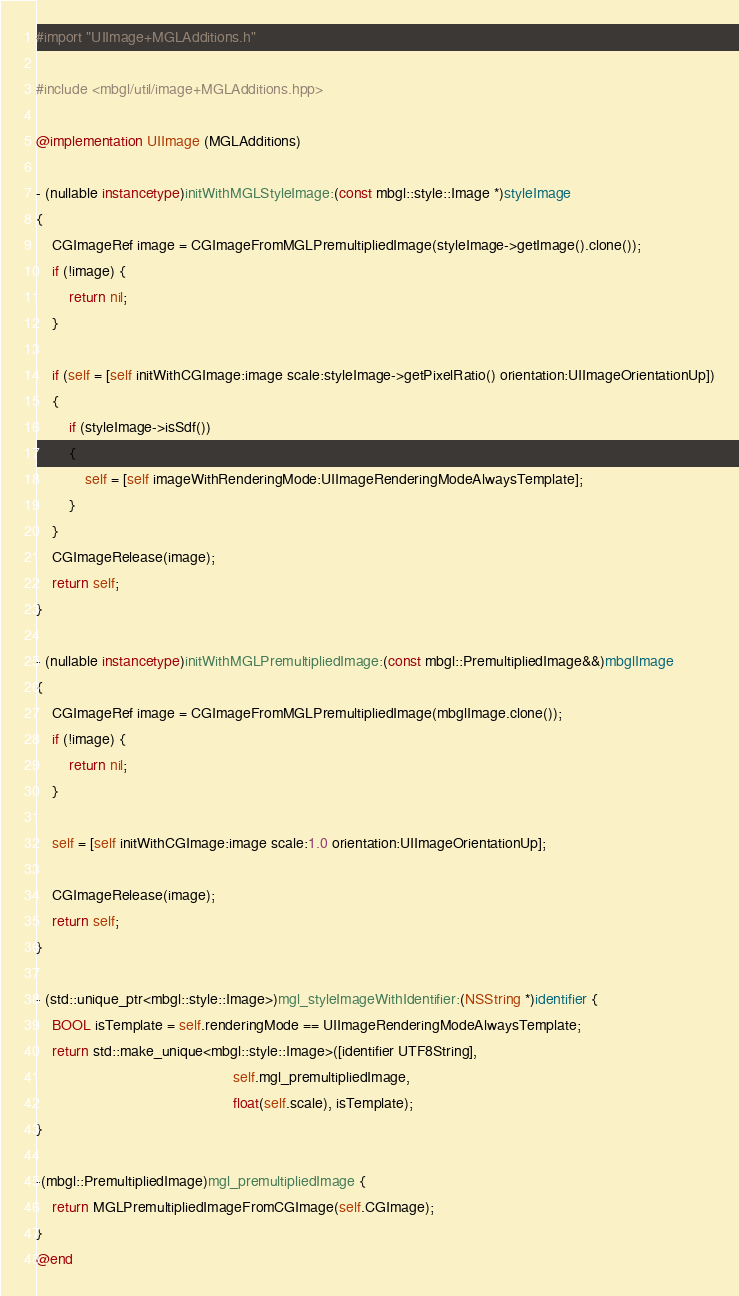Convert code to text. <code><loc_0><loc_0><loc_500><loc_500><_ObjectiveC_>#import "UIImage+MGLAdditions.h"

#include <mbgl/util/image+MGLAdditions.hpp>

@implementation UIImage (MGLAdditions)

- (nullable instancetype)initWithMGLStyleImage:(const mbgl::style::Image *)styleImage
{
    CGImageRef image = CGImageFromMGLPremultipliedImage(styleImage->getImage().clone());
    if (!image) {
        return nil;
    }

    if (self = [self initWithCGImage:image scale:styleImage->getPixelRatio() orientation:UIImageOrientationUp])
    {
        if (styleImage->isSdf())
        {
            self = [self imageWithRenderingMode:UIImageRenderingModeAlwaysTemplate];
        }
    }
    CGImageRelease(image);
    return self;
}

- (nullable instancetype)initWithMGLPremultipliedImage:(const mbgl::PremultipliedImage&&)mbglImage
{
    CGImageRef image = CGImageFromMGLPremultipliedImage(mbglImage.clone());
    if (!image) {
        return nil;
    }

    self = [self initWithCGImage:image scale:1.0 orientation:UIImageOrientationUp];
    
    CGImageRelease(image);
    return self;
}

- (std::unique_ptr<mbgl::style::Image>)mgl_styleImageWithIdentifier:(NSString *)identifier {
    BOOL isTemplate = self.renderingMode == UIImageRenderingModeAlwaysTemplate;
    return std::make_unique<mbgl::style::Image>([identifier UTF8String],
                                                self.mgl_premultipliedImage,
                                                float(self.scale), isTemplate);
}

-(mbgl::PremultipliedImage)mgl_premultipliedImage {
    return MGLPremultipliedImageFromCGImage(self.CGImage);
}
@end
</code> 